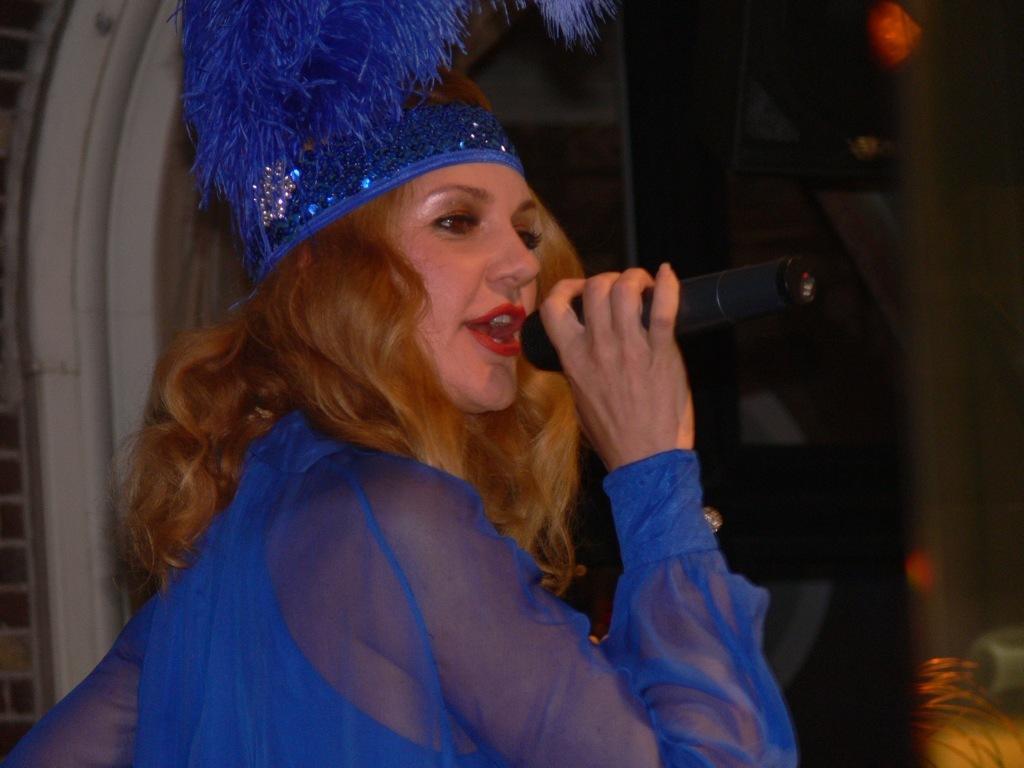Could you give a brief overview of what you see in this image? In the image we can see one person standing and holding microphone. She is singing,we can see her mouth is open. She is wearing hat which is in blue color. In the background there is a wall. 